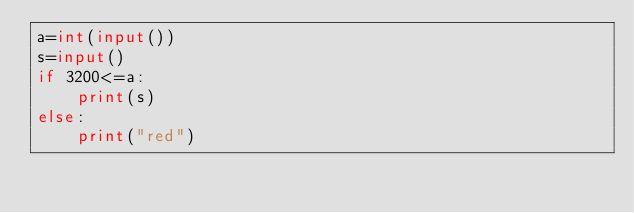<code> <loc_0><loc_0><loc_500><loc_500><_Python_>a=int(input())
s=input()
if 3200<=a:
    print(s)
else:
    print("red")</code> 